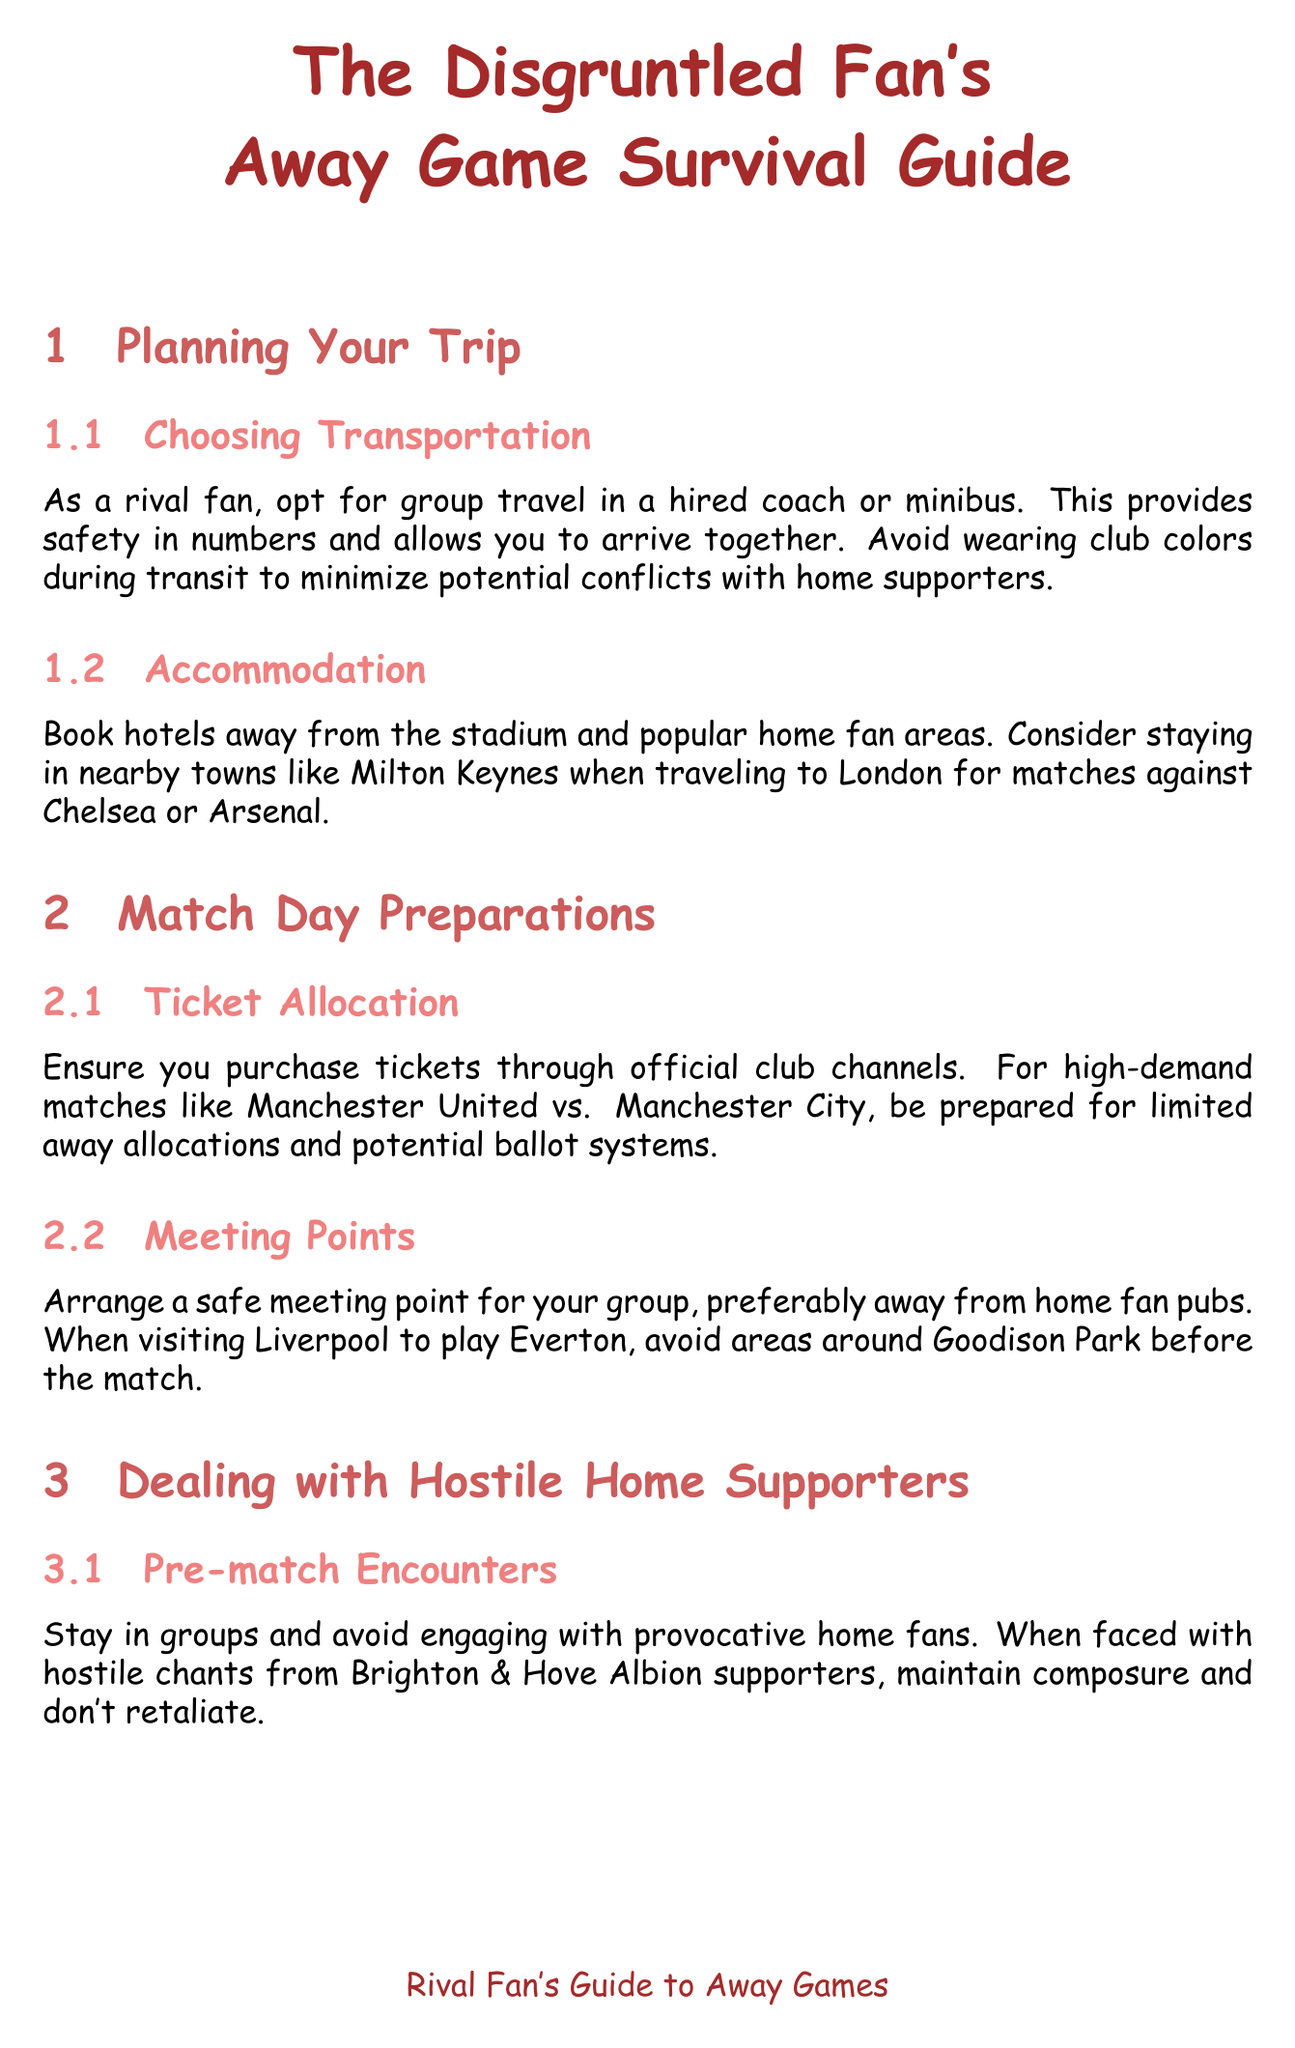What is a recommended mode of transportation for rival fans? The document suggests opting for group travel in a hired coach or minibus for safety in numbers.
Answer: hired coach or minibus Where should you book accommodation when attending away games? It is advised to book hotels away from the stadium and popular home fan areas.
Answer: away from the stadium What should you ensure when purchasing tickets for high-demand matches? You should purchase tickets through official club channels.
Answer: official club channels What is the primary advice for dealing with home fans prior to a match? It is advised to stay in groups and avoid engaging with provocative home fans.
Answer: stay in groups Where should away fans regroup after a match? Away fans should regroup at their designated meeting point.
Answer: designated meeting point What should you document concerning home supporters? Any instances of discrimination or abuse should be documented.
Answer: discrimination or abuse Which police unit offers travel advice for fans? The British Transport Police Football Unit provides travel advice and support.
Answer: British Transport Police Football Unit What is the title of the manual? The title indicates it is a guide tailored for disgruntled fans attending away games.
Answer: The Disgruntled Fan's Away Game Survival Guide 